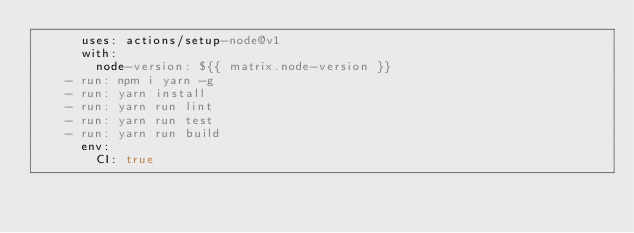Convert code to text. <code><loc_0><loc_0><loc_500><loc_500><_YAML_>      uses: actions/setup-node@v1
      with:
        node-version: ${{ matrix.node-version }}
    - run: npm i yarn -g
    - run: yarn install
    - run: yarn run lint
    - run: yarn run test
    - run: yarn run build
      env:
        CI: true  </code> 